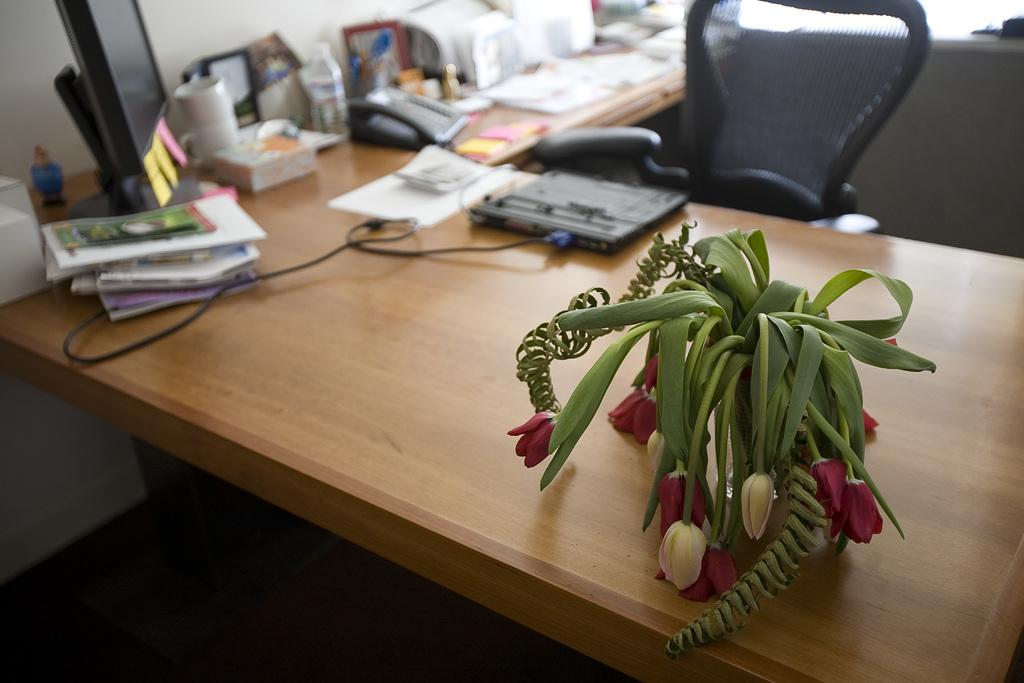What type of furniture is present in the image? There is a table and a chair in the image. What objects can be seen on the table? There are books and a computer system on top of the table. Is there any decorative item on the table? Yes, there is a flower vase on the table, located at the right side. Can you see any buildings or owls in the image? No, there are no buildings or owls present in the image. Is there a train visible in the image? No, there is no train visible in the image. 